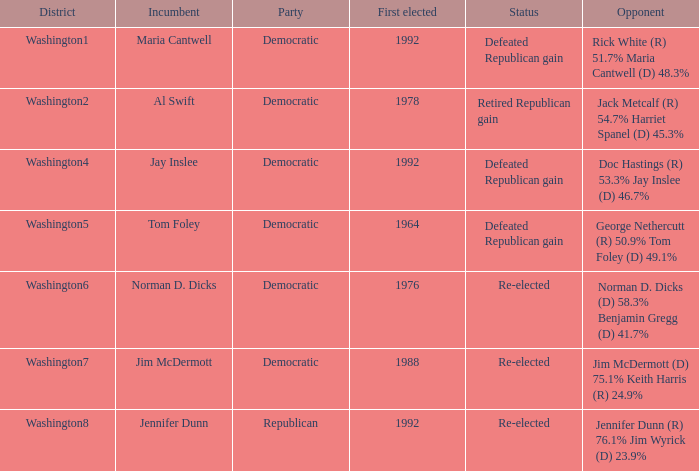What was the result of the election of doc hastings (r) 53.3% jay inslee (d) 46.7% Defeated Republican gain. 